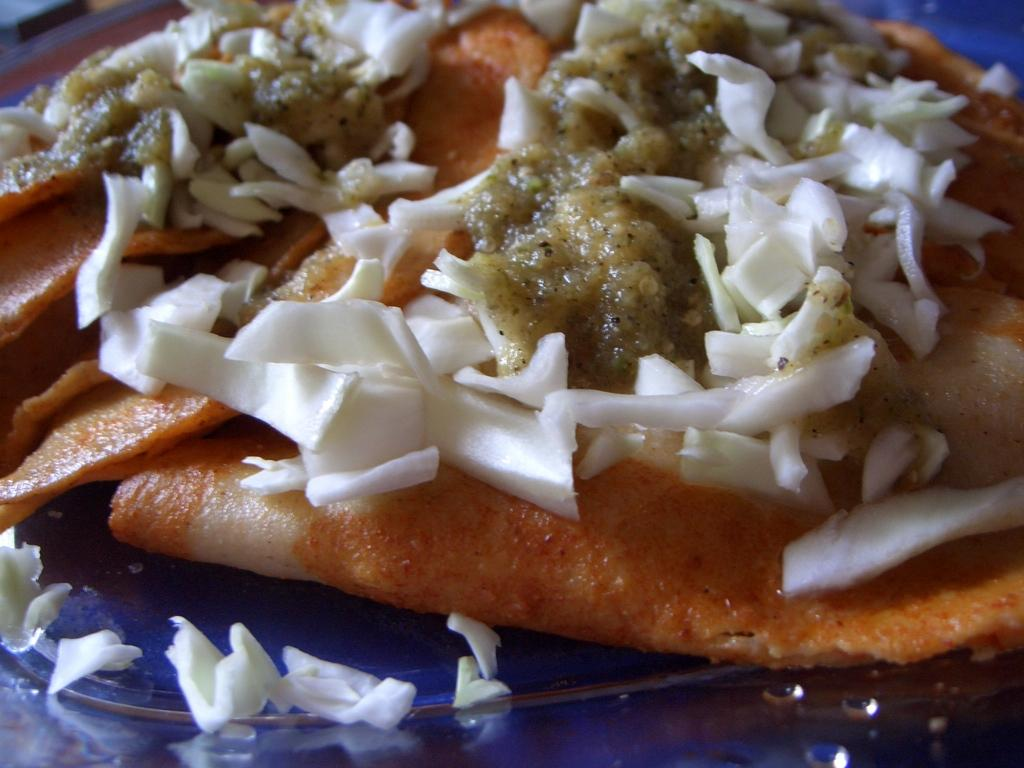What is the main subject of the image? There is an edible in the image. How is the edible presented in the image? The edible is placed on a plate. What type of channel can be seen in the image? There is no channel present in the image; it features an edible placed on a plate. What kind of jewel is adorning the edible in the image? There is no jewel present on the edible in the image. 